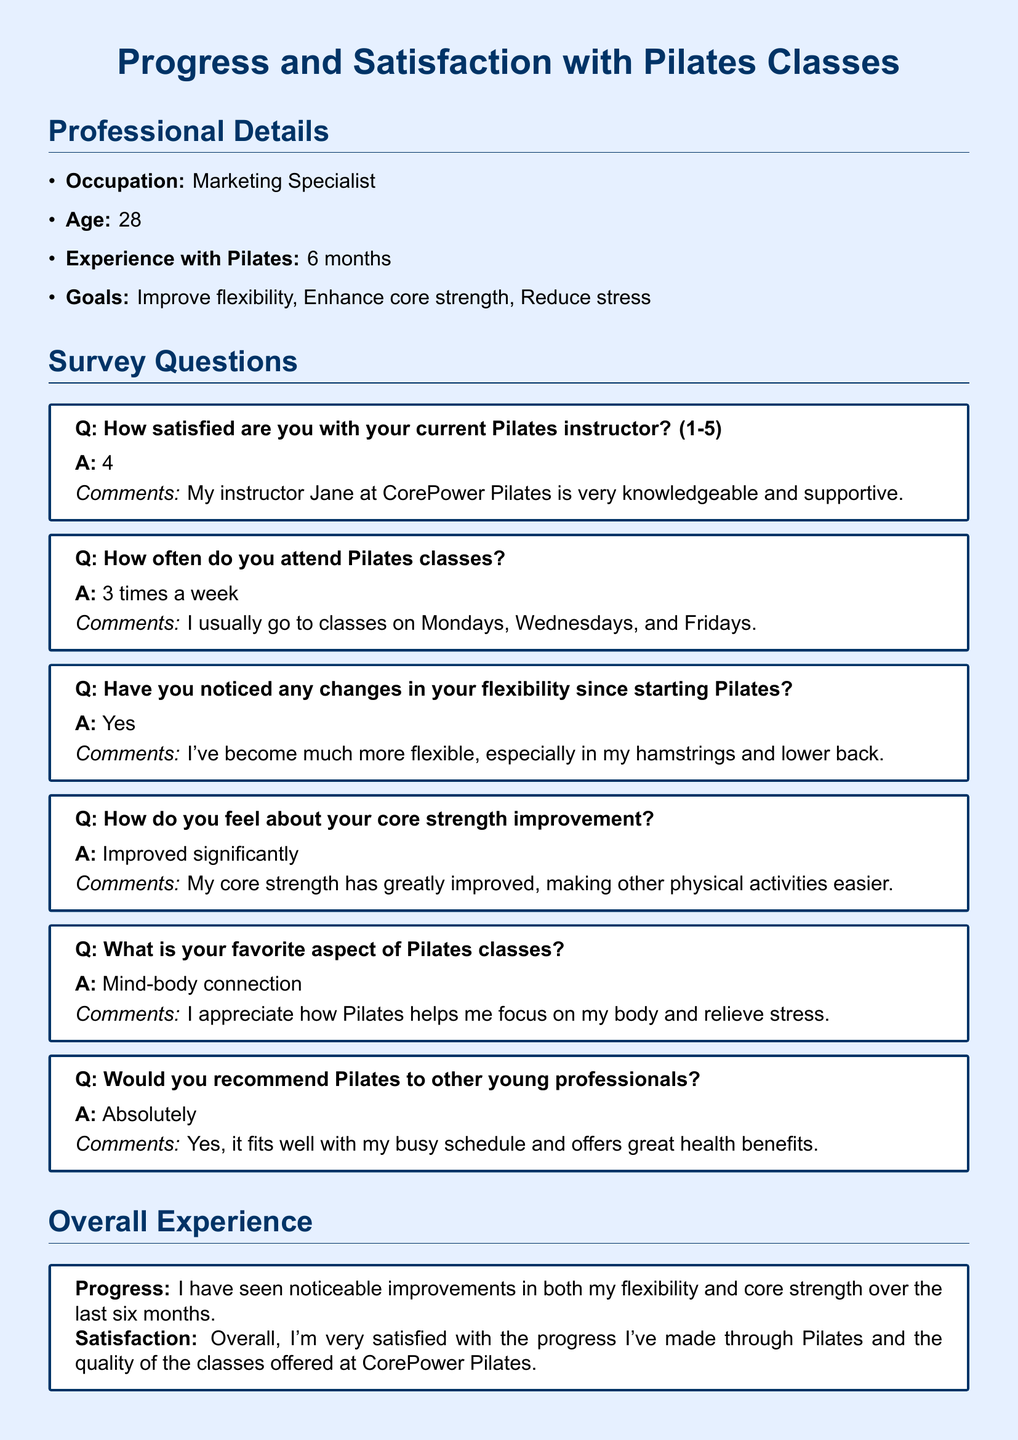What is the occupation of the respondent? The occupation is stated in the Professional Details section of the document.
Answer: Marketing Specialist How many times a week does the respondent attend Pilates classes? The frequency of attendance is explicitly mentioned in the survey questions section.
Answer: 3 times a week What is the name of the Pilates instructor mentioned? The instructor's name is given in the satisfaction question about the current instructor.
Answer: Jane What aspect of Pilates does the respondent appreciate the most? The favorite aspect is provided in the survey questions regarding what the respondent enjoys about the classes.
Answer: Mind-body connection How long has the respondent been practicing Pilates? The duration of practice is noted in the Professional Details section of the document.
Answer: 6 months Would the respondent recommend Pilates to others? The recommendation is found in the survey question focused on this topic.
Answer: Absolutely How significant are the improvements in core strength according to the respondent? This information is provided in the answer about core strength improvement.
Answer: Improved significantly What are the primary goals of the respondent regarding Pilates? The goals are detailed in the Professional Details section, enumerating the respondent's aims.
Answer: Improve flexibility, Enhance core strength, Reduce stress 